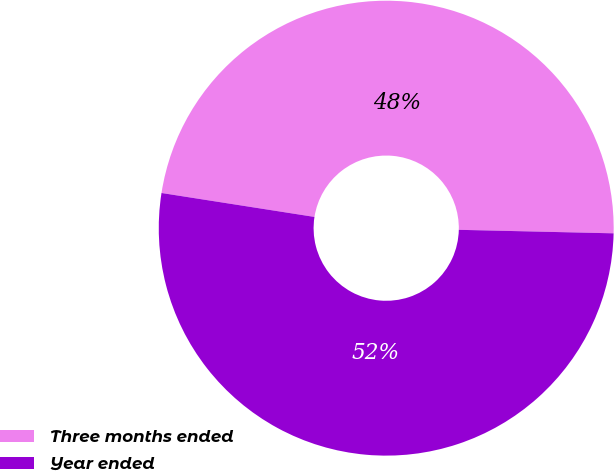Convert chart. <chart><loc_0><loc_0><loc_500><loc_500><pie_chart><fcel>Three months ended<fcel>Year ended<nl><fcel>47.89%<fcel>52.11%<nl></chart> 